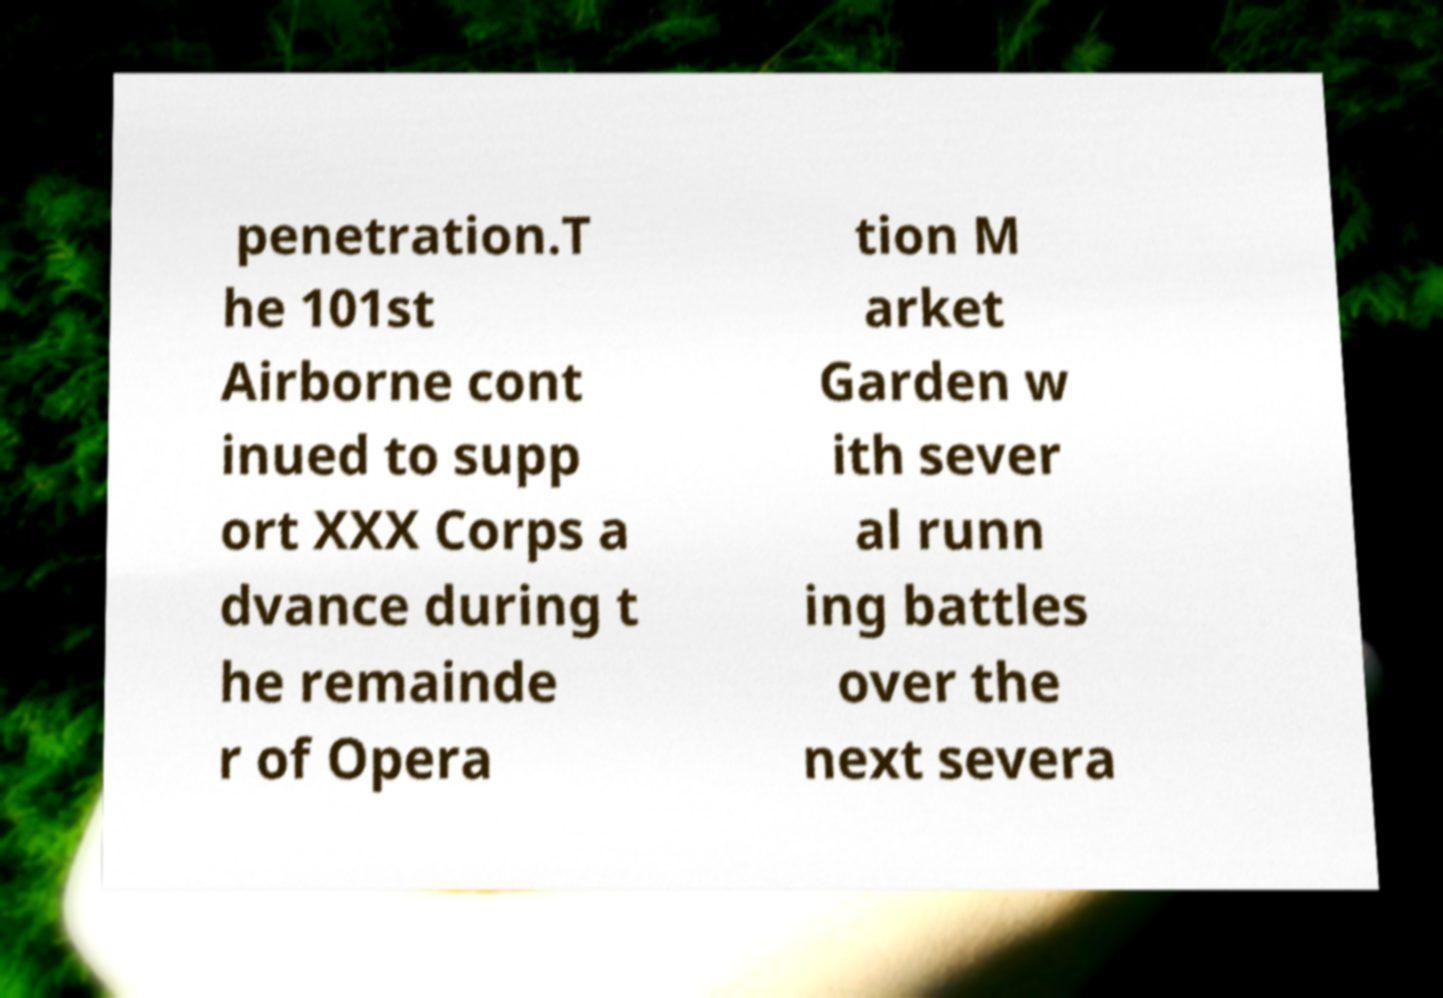There's text embedded in this image that I need extracted. Can you transcribe it verbatim? penetration.T he 101st Airborne cont inued to supp ort XXX Corps a dvance during t he remainde r of Opera tion M arket Garden w ith sever al runn ing battles over the next severa 